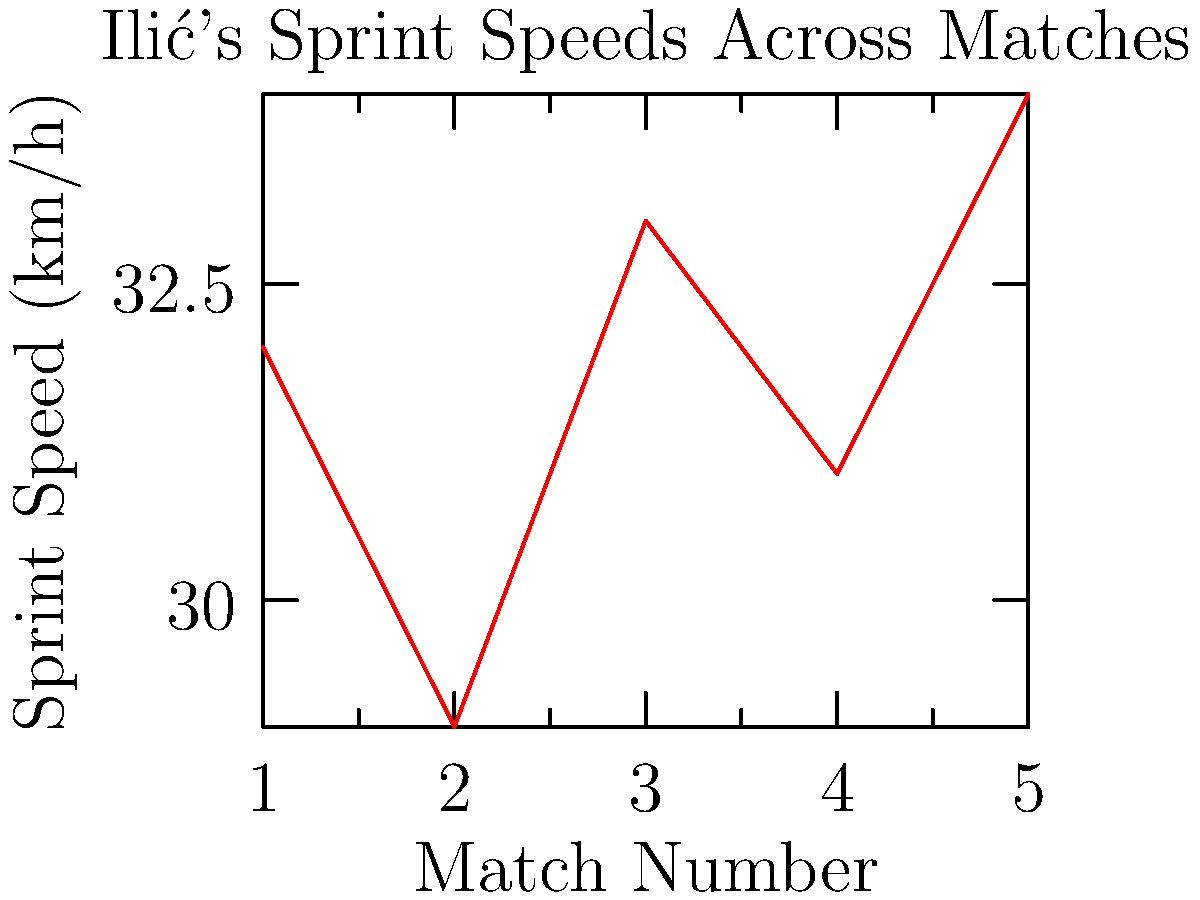Based on the line graph showing Veljko Ilić's sprint speeds across five matches, what is the difference in km/h between his highest and lowest recorded sprint speeds? To find the difference between Ilić's highest and lowest sprint speeds, we need to:

1. Identify the highest speed on the graph:
   The highest point on the graph is at match 5, showing a speed of 34 km/h.

2. Identify the lowest speed on the graph:
   The lowest point on the graph is at match 2, showing a speed of 29 km/h.

3. Calculate the difference:
   $34 \text{ km/h} - 29 \text{ km/h} = 5 \text{ km/h}$

Therefore, the difference between Ilić's highest and lowest recorded sprint speeds is 5 km/h.
Answer: 5 km/h 